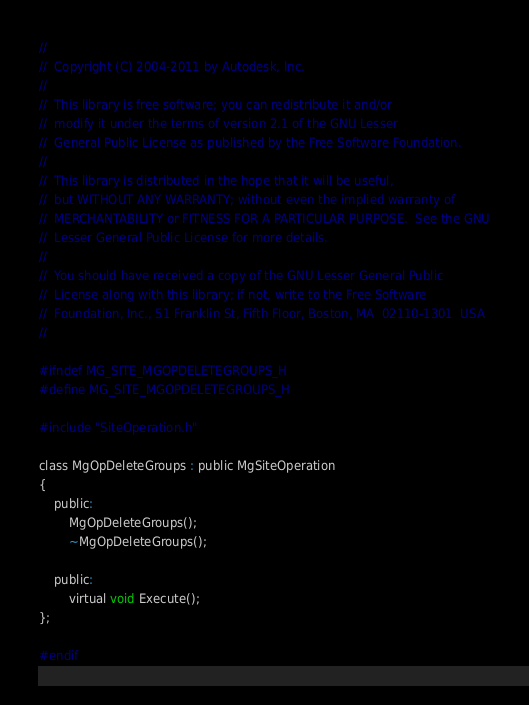Convert code to text. <code><loc_0><loc_0><loc_500><loc_500><_C_>//
//  Copyright (C) 2004-2011 by Autodesk, Inc.
//
//  This library is free software; you can redistribute it and/or
//  modify it under the terms of version 2.1 of the GNU Lesser
//  General Public License as published by the Free Software Foundation.
//
//  This library is distributed in the hope that it will be useful,
//  but WITHOUT ANY WARRANTY; without even the implied warranty of
//  MERCHANTABILITY or FITNESS FOR A PARTICULAR PURPOSE.  See the GNU
//  Lesser General Public License for more details.
//
//  You should have received a copy of the GNU Lesser General Public
//  License along with this library; if not, write to the Free Software
//  Foundation, Inc., 51 Franklin St, Fifth Floor, Boston, MA  02110-1301  USA
//

#ifndef MG_SITE_MGOPDELETEGROUPS_H
#define MG_SITE_MGOPDELETEGROUPS_H

#include "SiteOperation.h"

class MgOpDeleteGroups : public MgSiteOperation
{
    public:
        MgOpDeleteGroups();
        ~MgOpDeleteGroups();

    public:
        virtual void Execute();
};

#endif
</code> 